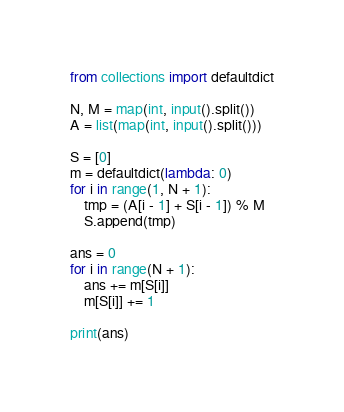<code> <loc_0><loc_0><loc_500><loc_500><_Python_>from collections import defaultdict

N, M = map(int, input().split())
A = list(map(int, input().split()))

S = [0]
m = defaultdict(lambda: 0)
for i in range(1, N + 1):
    tmp = (A[i - 1] + S[i - 1]) % M
    S.append(tmp)

ans = 0
for i in range(N + 1):
    ans += m[S[i]]
    m[S[i]] += 1

print(ans)</code> 